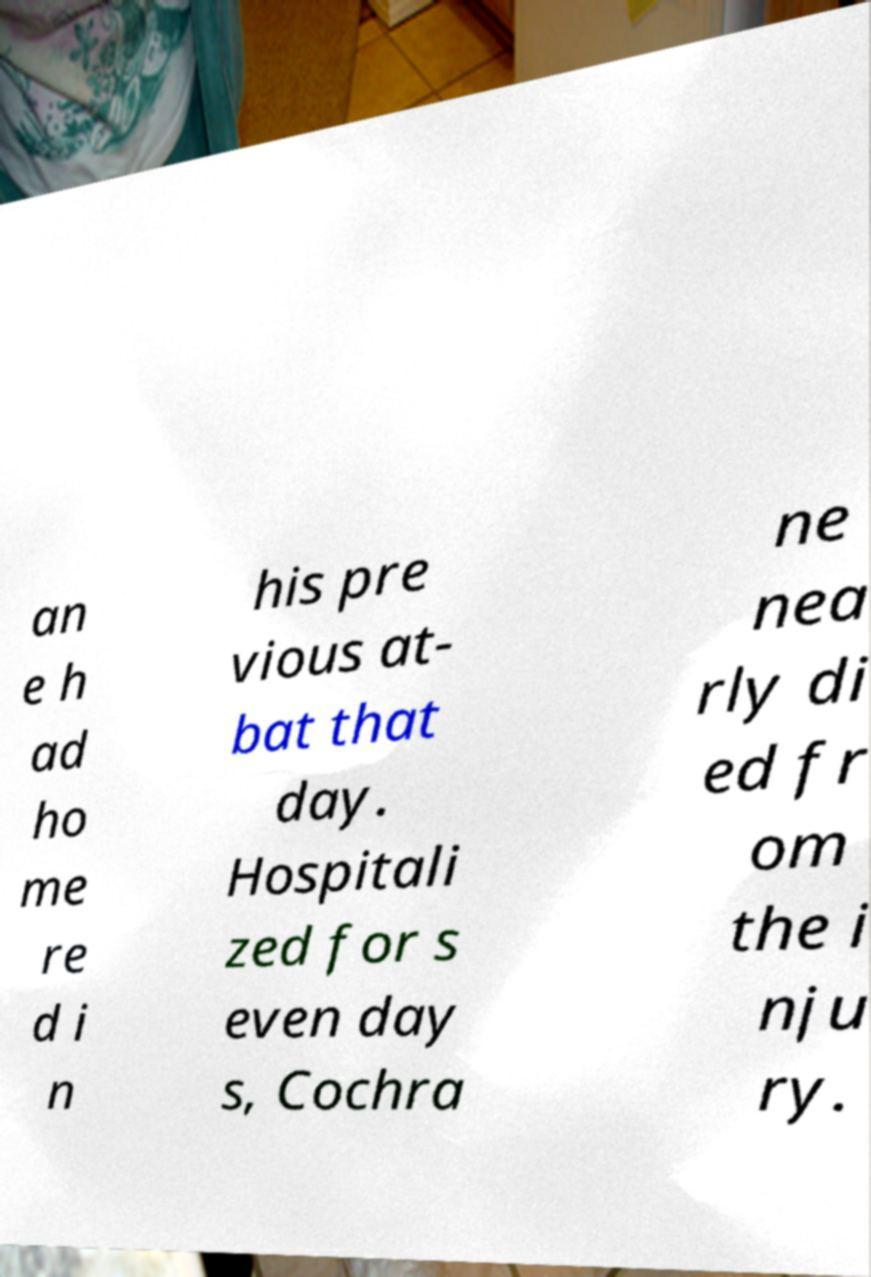Can you accurately transcribe the text from the provided image for me? an e h ad ho me re d i n his pre vious at- bat that day. Hospitali zed for s even day s, Cochra ne nea rly di ed fr om the i nju ry. 